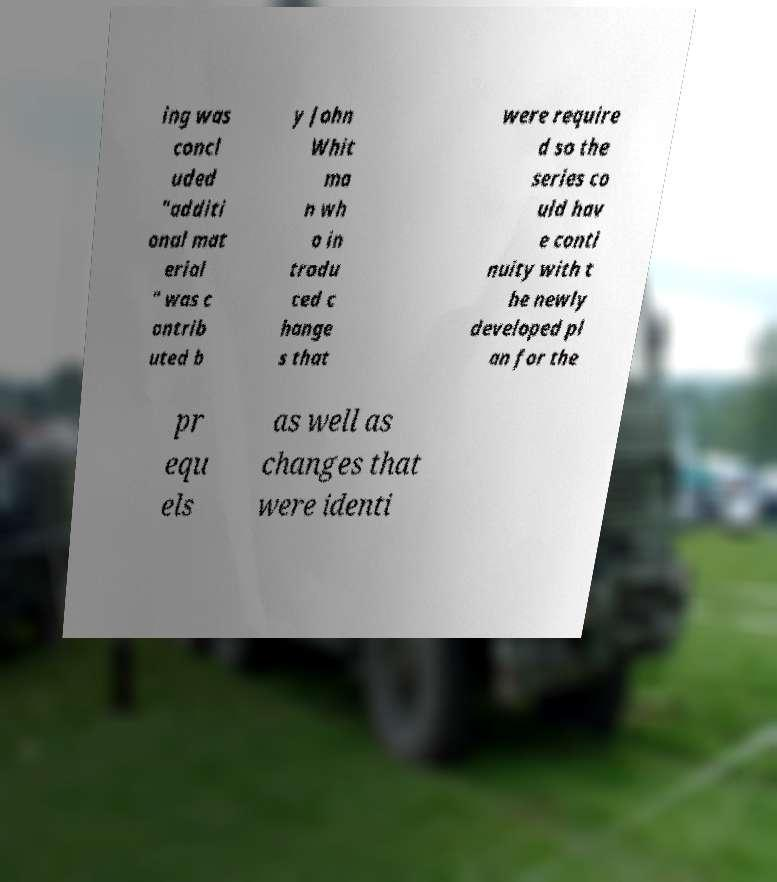Could you extract and type out the text from this image? ing was concl uded "additi onal mat erial " was c ontrib uted b y John Whit ma n wh o in trodu ced c hange s that were require d so the series co uld hav e conti nuity with t he newly developed pl an for the pr equ els as well as changes that were identi 